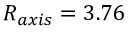Convert formula to latex. <formula><loc_0><loc_0><loc_500><loc_500>R _ { a x i s } = 3 . 7 6</formula> 